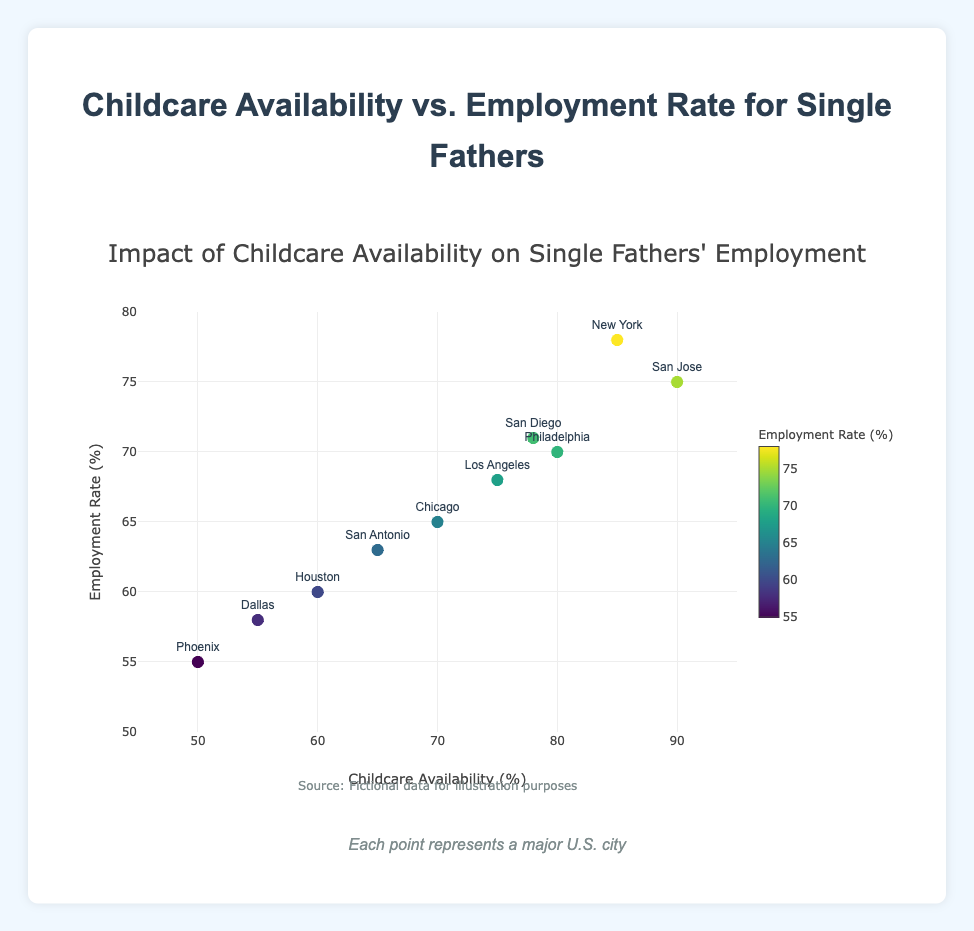What is the title of the plot? The title is typically the largest text at the top of the plot, providing an overall description.
Answer: Childcare Availability vs. Employment Rate for Single Fathers How many data points are displayed in the plot? Each city represents one data point, so the total count equals the number of cities.
Answer: 10 Which city has the highest childcare availability? By looking at the x-axis values, we can identify the city corresponding to the highest percentage.
Answer: San Jose Which city has the lowest employment rate for single fathers? By comparing all y-axis values, we find the city with the lowest rate.
Answer: Phoenix What is the employment rate in New York? We find New York in the plot, and then check the corresponding y-axis value.
Answer: 78% Is there a positive correlation between childcare availability and employment rate? By observing the general direction of the data points from lower-left to upper-right, we determine if a positive relationship exists.
Answer: Yes How much higher is the childcare availability in San Jose compared to Phoenix? Subtract Phoenix's childcare availability from San Jose's.
Answer: 90% - 50% = 40% Which city has a higher employment rate, Los Angeles or Philadelphia? Compare the y-axis values of Los Angeles and Philadelphia.
Answer: Philadelphia 